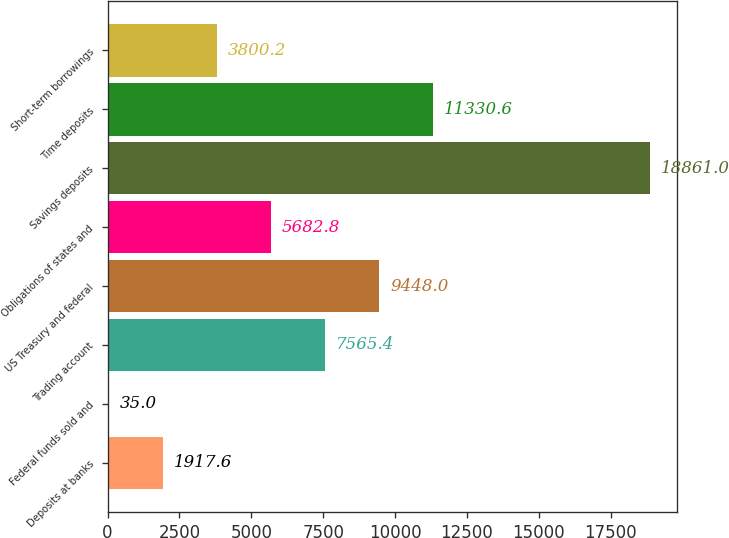<chart> <loc_0><loc_0><loc_500><loc_500><bar_chart><fcel>Deposits at banks<fcel>Federal funds sold and<fcel>Trading account<fcel>US Treasury and federal<fcel>Obligations of states and<fcel>Savings deposits<fcel>Time deposits<fcel>Short-term borrowings<nl><fcel>1917.6<fcel>35<fcel>7565.4<fcel>9448<fcel>5682.8<fcel>18861<fcel>11330.6<fcel>3800.2<nl></chart> 